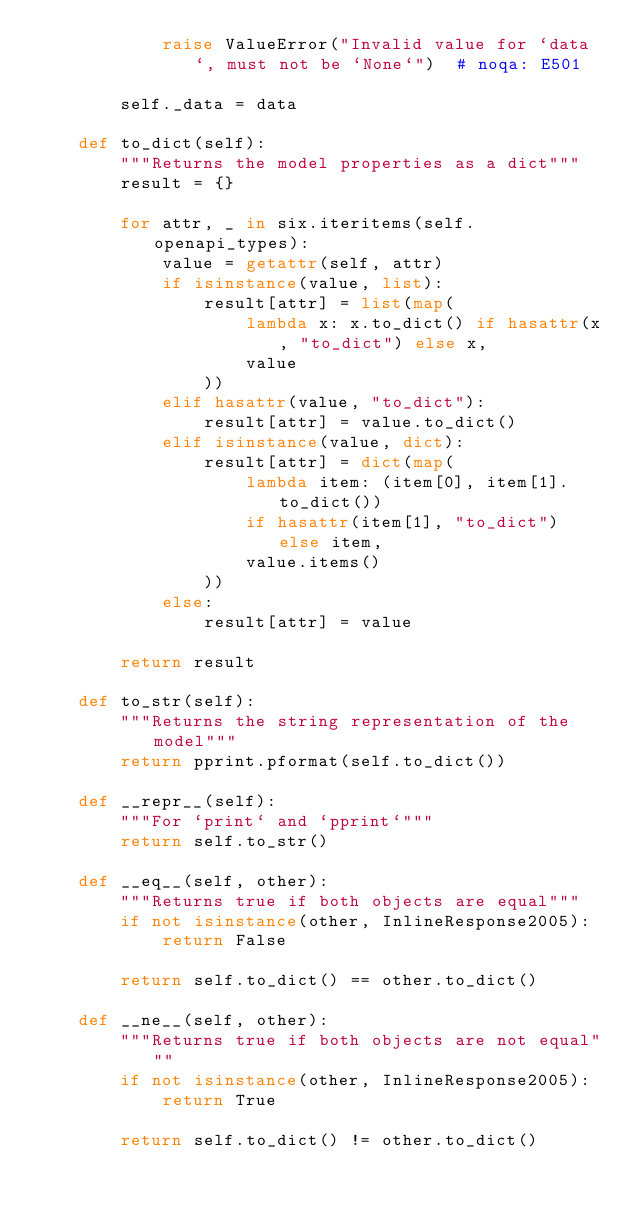Convert code to text. <code><loc_0><loc_0><loc_500><loc_500><_Python_>            raise ValueError("Invalid value for `data`, must not be `None`")  # noqa: E501

        self._data = data

    def to_dict(self):
        """Returns the model properties as a dict"""
        result = {}

        for attr, _ in six.iteritems(self.openapi_types):
            value = getattr(self, attr)
            if isinstance(value, list):
                result[attr] = list(map(
                    lambda x: x.to_dict() if hasattr(x, "to_dict") else x,
                    value
                ))
            elif hasattr(value, "to_dict"):
                result[attr] = value.to_dict()
            elif isinstance(value, dict):
                result[attr] = dict(map(
                    lambda item: (item[0], item[1].to_dict())
                    if hasattr(item[1], "to_dict") else item,
                    value.items()
                ))
            else:
                result[attr] = value

        return result

    def to_str(self):
        """Returns the string representation of the model"""
        return pprint.pformat(self.to_dict())

    def __repr__(self):
        """For `print` and `pprint`"""
        return self.to_str()

    def __eq__(self, other):
        """Returns true if both objects are equal"""
        if not isinstance(other, InlineResponse2005):
            return False

        return self.to_dict() == other.to_dict()

    def __ne__(self, other):
        """Returns true if both objects are not equal"""
        if not isinstance(other, InlineResponse2005):
            return True

        return self.to_dict() != other.to_dict()
</code> 